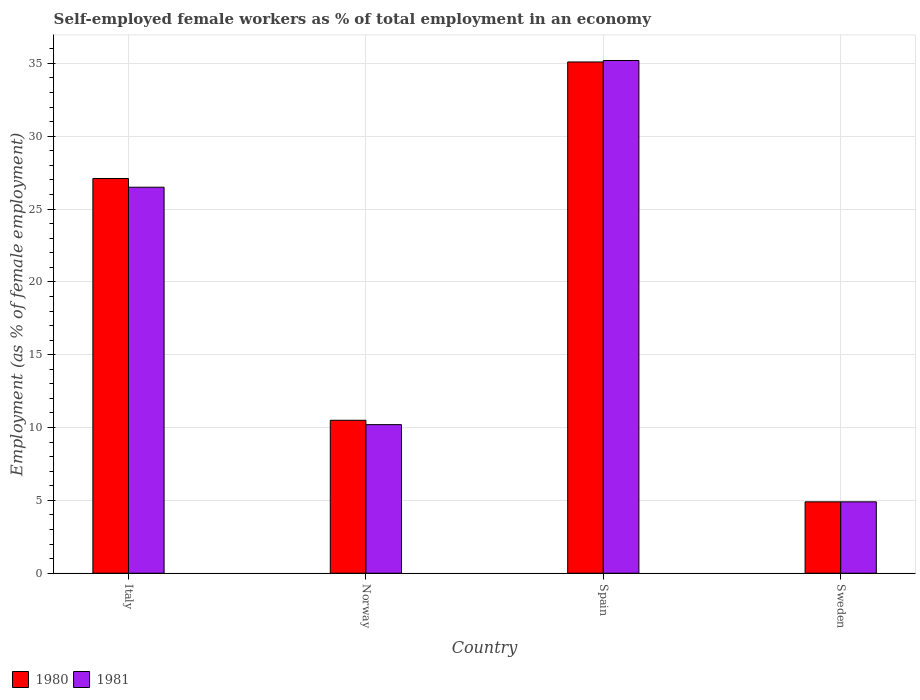Are the number of bars per tick equal to the number of legend labels?
Offer a terse response. Yes. How many bars are there on the 4th tick from the left?
Offer a terse response. 2. What is the label of the 2nd group of bars from the left?
Your answer should be compact. Norway. Across all countries, what is the maximum percentage of self-employed female workers in 1980?
Keep it short and to the point. 35.1. Across all countries, what is the minimum percentage of self-employed female workers in 1980?
Provide a succinct answer. 4.9. What is the total percentage of self-employed female workers in 1980 in the graph?
Your answer should be compact. 77.6. What is the difference between the percentage of self-employed female workers in 1981 in Norway and that in Sweden?
Your response must be concise. 5.3. What is the difference between the percentage of self-employed female workers in 1980 in Sweden and the percentage of self-employed female workers in 1981 in Italy?
Offer a terse response. -21.6. What is the average percentage of self-employed female workers in 1981 per country?
Your answer should be compact. 19.2. What is the ratio of the percentage of self-employed female workers in 1980 in Italy to that in Sweden?
Your response must be concise. 5.53. What is the difference between the highest and the second highest percentage of self-employed female workers in 1981?
Provide a succinct answer. -8.7. What is the difference between the highest and the lowest percentage of self-employed female workers in 1981?
Make the answer very short. 30.3. Is the sum of the percentage of self-employed female workers in 1981 in Italy and Norway greater than the maximum percentage of self-employed female workers in 1980 across all countries?
Give a very brief answer. Yes. What does the 1st bar from the right in Norway represents?
Your answer should be very brief. 1981. How many bars are there?
Your response must be concise. 8. What is the difference between two consecutive major ticks on the Y-axis?
Give a very brief answer. 5. Does the graph contain any zero values?
Ensure brevity in your answer.  No. Where does the legend appear in the graph?
Your answer should be compact. Bottom left. How many legend labels are there?
Your answer should be compact. 2. What is the title of the graph?
Offer a terse response. Self-employed female workers as % of total employment in an economy. Does "1967" appear as one of the legend labels in the graph?
Offer a very short reply. No. What is the label or title of the X-axis?
Keep it short and to the point. Country. What is the label or title of the Y-axis?
Give a very brief answer. Employment (as % of female employment). What is the Employment (as % of female employment) of 1980 in Italy?
Your answer should be very brief. 27.1. What is the Employment (as % of female employment) of 1981 in Italy?
Offer a very short reply. 26.5. What is the Employment (as % of female employment) of 1981 in Norway?
Keep it short and to the point. 10.2. What is the Employment (as % of female employment) of 1980 in Spain?
Your response must be concise. 35.1. What is the Employment (as % of female employment) in 1981 in Spain?
Your response must be concise. 35.2. What is the Employment (as % of female employment) of 1980 in Sweden?
Your answer should be very brief. 4.9. What is the Employment (as % of female employment) of 1981 in Sweden?
Make the answer very short. 4.9. Across all countries, what is the maximum Employment (as % of female employment) of 1980?
Provide a short and direct response. 35.1. Across all countries, what is the maximum Employment (as % of female employment) in 1981?
Your answer should be compact. 35.2. Across all countries, what is the minimum Employment (as % of female employment) of 1980?
Keep it short and to the point. 4.9. Across all countries, what is the minimum Employment (as % of female employment) of 1981?
Offer a very short reply. 4.9. What is the total Employment (as % of female employment) in 1980 in the graph?
Give a very brief answer. 77.6. What is the total Employment (as % of female employment) of 1981 in the graph?
Provide a short and direct response. 76.8. What is the difference between the Employment (as % of female employment) in 1981 in Italy and that in Norway?
Your answer should be compact. 16.3. What is the difference between the Employment (as % of female employment) in 1981 in Italy and that in Spain?
Offer a very short reply. -8.7. What is the difference between the Employment (as % of female employment) of 1981 in Italy and that in Sweden?
Your answer should be very brief. 21.6. What is the difference between the Employment (as % of female employment) in 1980 in Norway and that in Spain?
Offer a terse response. -24.6. What is the difference between the Employment (as % of female employment) in 1980 in Norway and that in Sweden?
Your answer should be compact. 5.6. What is the difference between the Employment (as % of female employment) of 1980 in Spain and that in Sweden?
Provide a short and direct response. 30.2. What is the difference between the Employment (as % of female employment) of 1981 in Spain and that in Sweden?
Provide a short and direct response. 30.3. What is the difference between the Employment (as % of female employment) of 1980 in Italy and the Employment (as % of female employment) of 1981 in Norway?
Offer a terse response. 16.9. What is the difference between the Employment (as % of female employment) in 1980 in Norway and the Employment (as % of female employment) in 1981 in Spain?
Your answer should be compact. -24.7. What is the difference between the Employment (as % of female employment) of 1980 in Norway and the Employment (as % of female employment) of 1981 in Sweden?
Ensure brevity in your answer.  5.6. What is the difference between the Employment (as % of female employment) in 1980 in Spain and the Employment (as % of female employment) in 1981 in Sweden?
Ensure brevity in your answer.  30.2. What is the difference between the Employment (as % of female employment) of 1980 and Employment (as % of female employment) of 1981 in Norway?
Make the answer very short. 0.3. What is the difference between the Employment (as % of female employment) of 1980 and Employment (as % of female employment) of 1981 in Spain?
Offer a very short reply. -0.1. What is the difference between the Employment (as % of female employment) in 1980 and Employment (as % of female employment) in 1981 in Sweden?
Offer a terse response. 0. What is the ratio of the Employment (as % of female employment) of 1980 in Italy to that in Norway?
Offer a very short reply. 2.58. What is the ratio of the Employment (as % of female employment) of 1981 in Italy to that in Norway?
Your answer should be very brief. 2.6. What is the ratio of the Employment (as % of female employment) in 1980 in Italy to that in Spain?
Give a very brief answer. 0.77. What is the ratio of the Employment (as % of female employment) of 1981 in Italy to that in Spain?
Your response must be concise. 0.75. What is the ratio of the Employment (as % of female employment) in 1980 in Italy to that in Sweden?
Provide a short and direct response. 5.53. What is the ratio of the Employment (as % of female employment) of 1981 in Italy to that in Sweden?
Your answer should be very brief. 5.41. What is the ratio of the Employment (as % of female employment) of 1980 in Norway to that in Spain?
Offer a terse response. 0.3. What is the ratio of the Employment (as % of female employment) of 1981 in Norway to that in Spain?
Give a very brief answer. 0.29. What is the ratio of the Employment (as % of female employment) of 1980 in Norway to that in Sweden?
Keep it short and to the point. 2.14. What is the ratio of the Employment (as % of female employment) of 1981 in Norway to that in Sweden?
Offer a very short reply. 2.08. What is the ratio of the Employment (as % of female employment) in 1980 in Spain to that in Sweden?
Provide a short and direct response. 7.16. What is the ratio of the Employment (as % of female employment) of 1981 in Spain to that in Sweden?
Provide a short and direct response. 7.18. What is the difference between the highest and the second highest Employment (as % of female employment) in 1980?
Keep it short and to the point. 8. What is the difference between the highest and the lowest Employment (as % of female employment) of 1980?
Provide a short and direct response. 30.2. What is the difference between the highest and the lowest Employment (as % of female employment) of 1981?
Give a very brief answer. 30.3. 